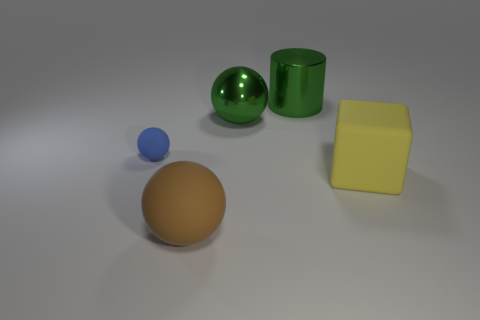Subtract all matte balls. How many balls are left? 1 Subtract all blue spheres. How many spheres are left? 2 Subtract all cylinders. How many objects are left? 4 Subtract 1 cylinders. How many cylinders are left? 0 Add 3 tiny blue matte things. How many tiny blue matte things are left? 4 Add 4 brown matte balls. How many brown matte balls exist? 5 Add 3 tiny red rubber spheres. How many objects exist? 8 Subtract 0 cyan cylinders. How many objects are left? 5 Subtract all purple blocks. Subtract all purple balls. How many blocks are left? 1 Subtract all brown blocks. How many blue spheres are left? 1 